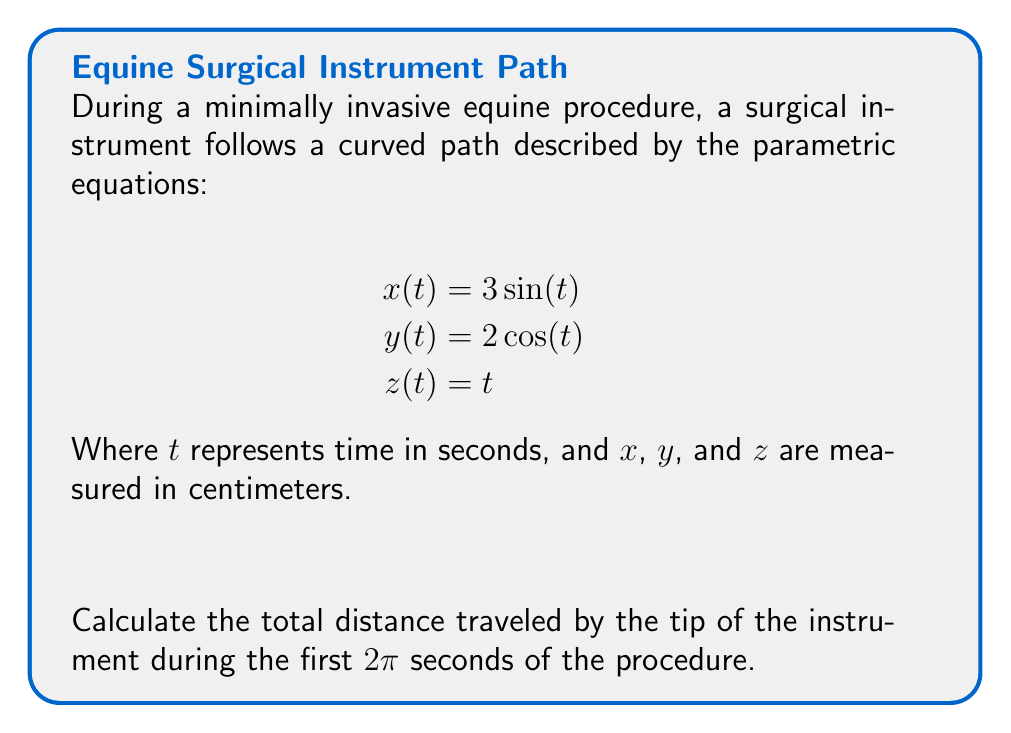Solve this math problem. To find the total distance traveled, we need to calculate the arc length of the curve over the given time interval. The formula for arc length in parametric form is:

$$L = \int_{a}^{b} \sqrt{\left(\frac{dx}{dt}\right)^2 + \left(\frac{dy}{dt}\right)^2 + \left(\frac{dz}{dt}\right)^2} dt$$

Step 1: Find the derivatives of x, y, and z with respect to t.
$$\frac{dx}{dt} = 3\cos(t)$$
$$\frac{dy}{dt} = -2\sin(t)$$
$$\frac{dz}{dt} = 1$$

Step 2: Substitute these into the arc length formula.
$$L = \int_{0}^{2\pi} \sqrt{(3\cos(t))^2 + (-2\sin(t))^2 + 1^2} dt$$

Step 3: Simplify the expression under the square root.
$$L = \int_{0}^{2\pi} \sqrt{9\cos^2(t) + 4\sin^2(t) + 1} dt$$

Step 4: Use the trigonometric identity $\cos^2(t) + \sin^2(t) = 1$ to simplify further.
$$L = \int_{0}^{2\pi} \sqrt{9(\cos^2(t) + \sin^2(t)) - 5\sin^2(t) + 1} dt$$
$$L = \int_{0}^{2\pi} \sqrt{10 - 5\sin^2(t)} dt$$

Step 5: This integral doesn't have an elementary antiderivative, so we need to evaluate it numerically. Using a numerical integration method (like Simpson's rule or a computer algebra system), we find:

$$L \approx 14.51 \text{ cm}$$
Answer: $14.51 \text{ cm}$ 